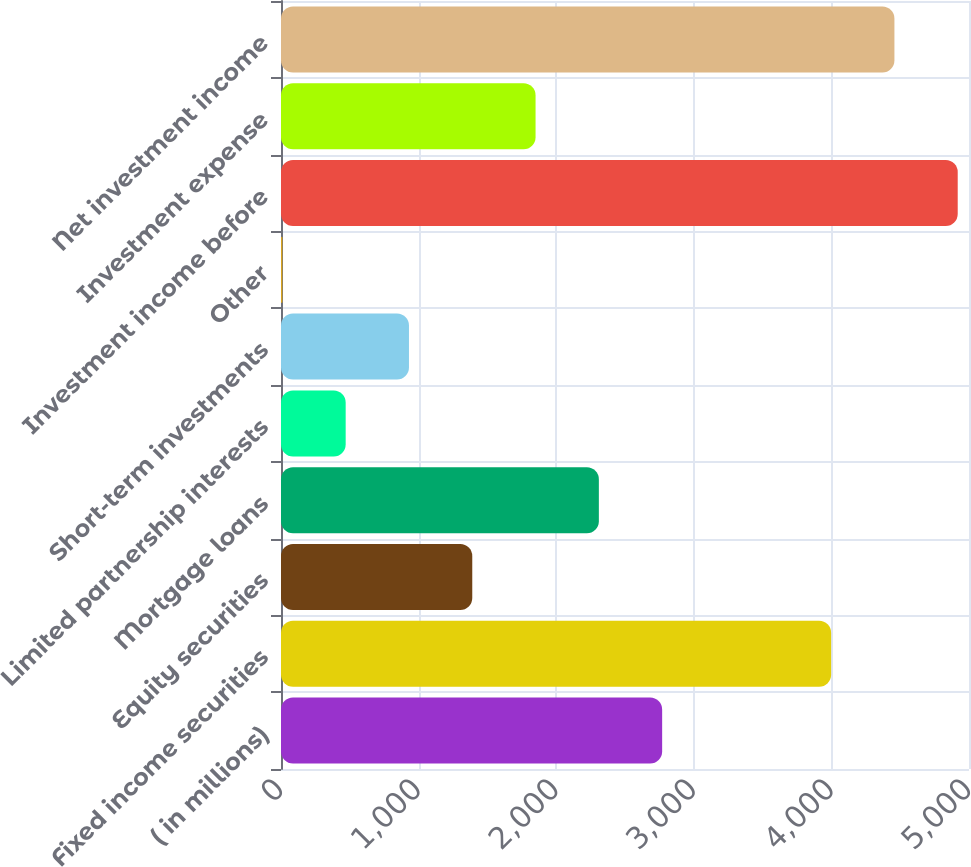Convert chart to OTSL. <chart><loc_0><loc_0><loc_500><loc_500><bar_chart><fcel>( in millions)<fcel>Fixed income securities<fcel>Equity securities<fcel>Mortgage loans<fcel>Limited partnership interests<fcel>Short-term investments<fcel>Other<fcel>Investment income before<fcel>Investment expense<fcel>Net investment income<nl><fcel>2770<fcel>3998<fcel>1390<fcel>2310<fcel>470<fcel>930<fcel>10<fcel>4918<fcel>1850<fcel>4458<nl></chart> 